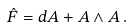<formula> <loc_0><loc_0><loc_500><loc_500>\hat { F } = d A + A \wedge A \, .</formula> 